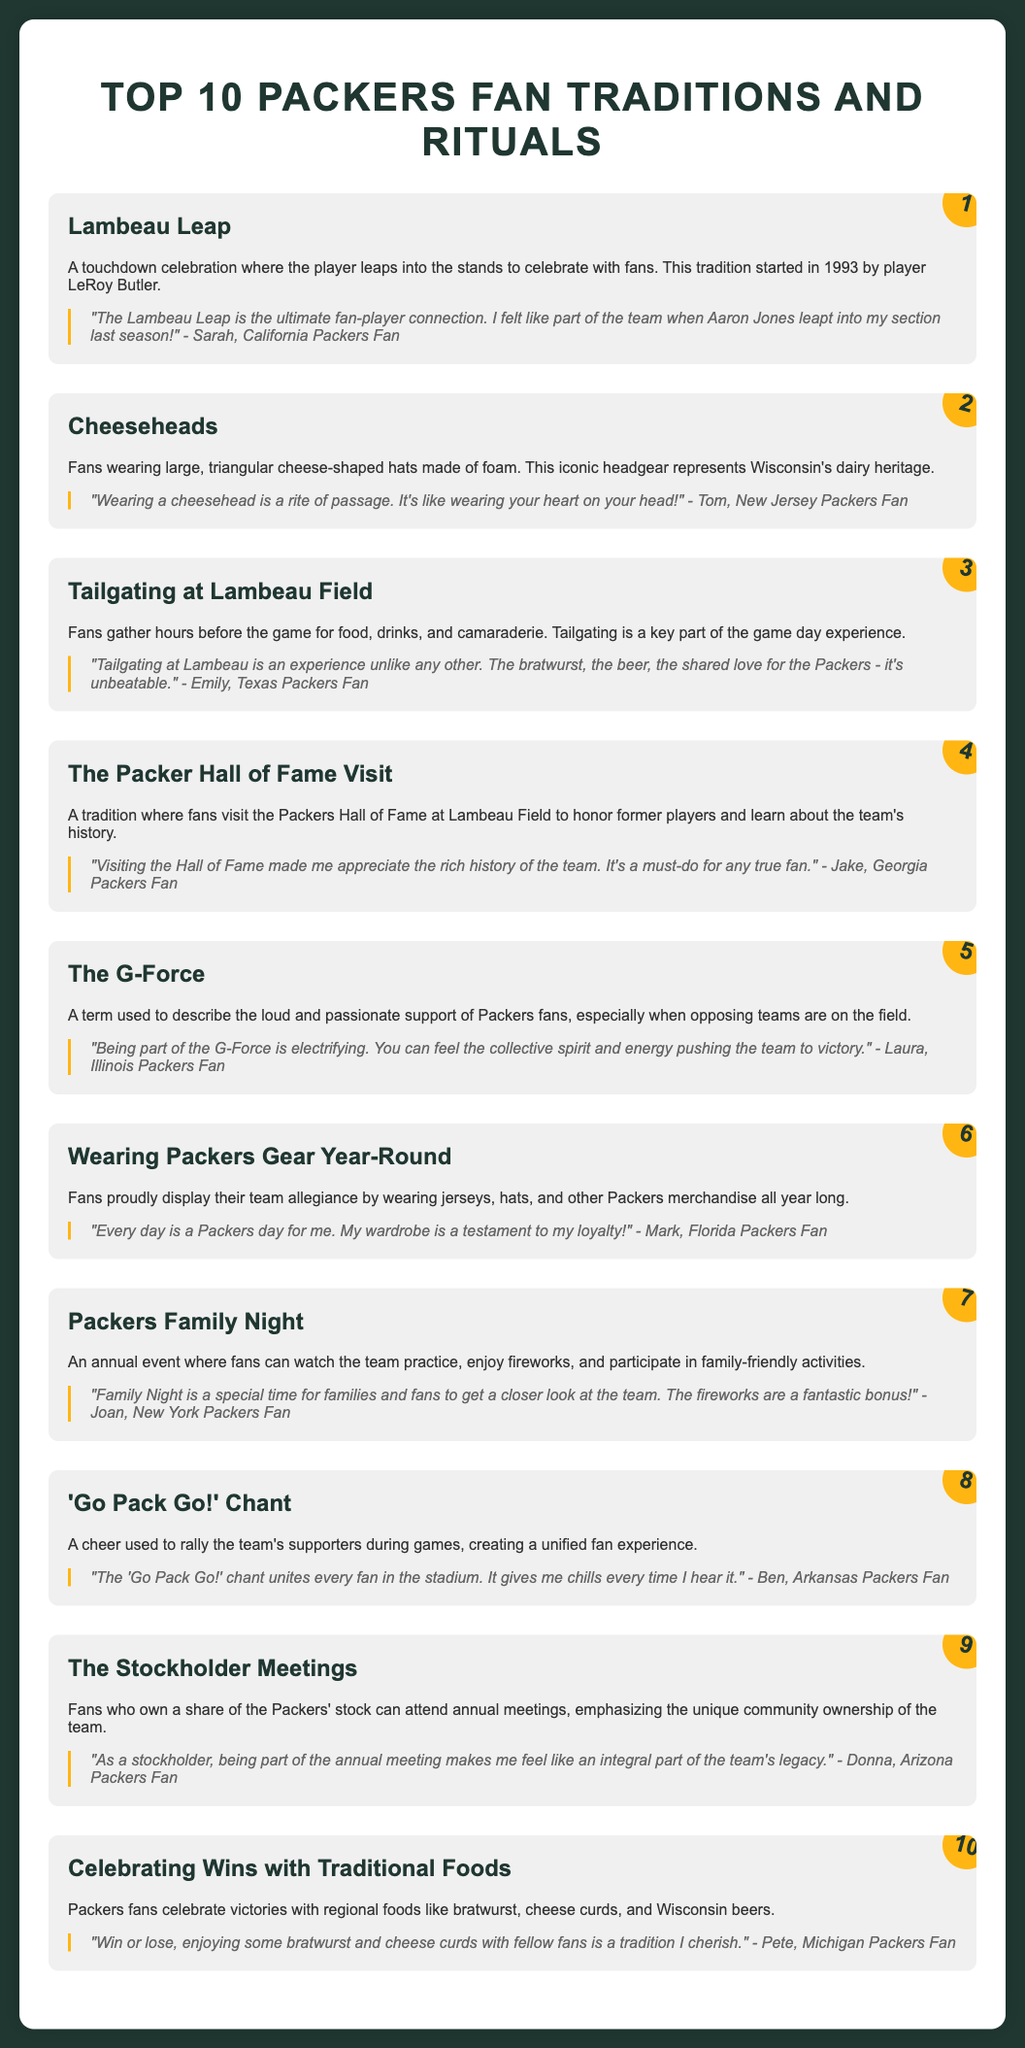What is the first Packers fan tradition listed? The first tradition is mentioned in the first section of the document, which is the Lambeau Leap.
Answer: Lambeau Leap Who started the Lambeau Leap tradition? The document credits player LeRoy Butler with starting the Lambeau Leap in 1993.
Answer: LeRoy Butler What do fans wear to represent Wisconsin's dairy heritage? The document states that fans wear large, triangular cheese-shaped hats made of foam.
Answer: Cheeseheads Which tradition involves watching the team practice and enjoying fireworks? The document describes an annual event where fans can watch practice and enjoy fireworks, which is Packers Family Night.
Answer: Packers Family Night How many traditions are listed in the document? The document explicitly states that there are ten traditions.
Answer: 10 Which tradition emphasizes unique community ownership of the team? The Stockholder Meetings highlight the unique community ownership of the Packers, according to the document.
Answer: The Stockholder Meetings What cheer is used to rally fans during games? The document mentions the 'Go Pack Go!' chant as a rallying cheer for fans during games.
Answer: 'Go Pack Go!' Chant What type of foods do Packers fans celebrate wins with? The document lists bratwurst, cheese curds, and Wisconsin beers as foods that fans celebrate wins with.
Answer: Traditional Foods Who is quoted as saying that wearing a cheesehead is a rite of passage? The document includes a quote from Tom, a New Jersey Packers Fan, about wearing a cheesehead.
Answer: Tom, New Jersey Packers Fan What is the color of the text used in the document? The body text color in the style section of the document is specified as #FFB612 for fan engagement.
Answer: #FFB612 